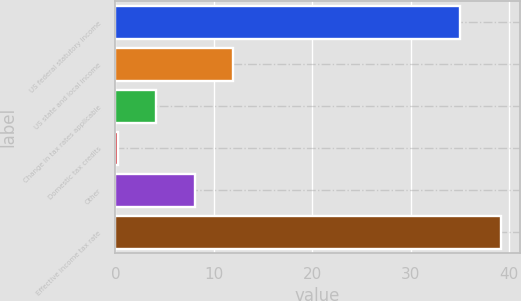Convert chart to OTSL. <chart><loc_0><loc_0><loc_500><loc_500><bar_chart><fcel>US federal statutory income<fcel>US state and local income<fcel>Change in tax rates applicable<fcel>Domestic tax credits<fcel>Other<fcel>Effective income tax rate<nl><fcel>35<fcel>11.94<fcel>4.16<fcel>0.27<fcel>8.05<fcel>39.14<nl></chart> 